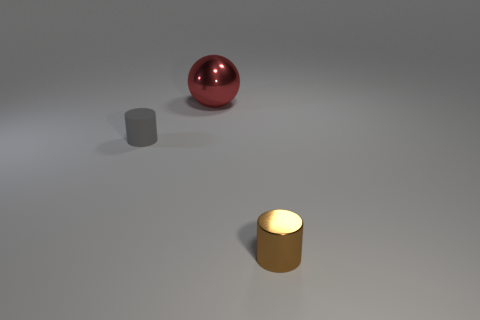Add 1 gray rubber cylinders. How many objects exist? 4 Subtract all brown cylinders. How many cylinders are left? 1 Subtract 0 gray cubes. How many objects are left? 3 Subtract all cylinders. How many objects are left? 1 Subtract 1 cylinders. How many cylinders are left? 1 Subtract all blue balls. Subtract all yellow cylinders. How many balls are left? 1 Subtract all big red spheres. Subtract all tiny gray matte objects. How many objects are left? 1 Add 1 tiny metal cylinders. How many tiny metal cylinders are left? 2 Add 2 gray rubber things. How many gray rubber things exist? 3 